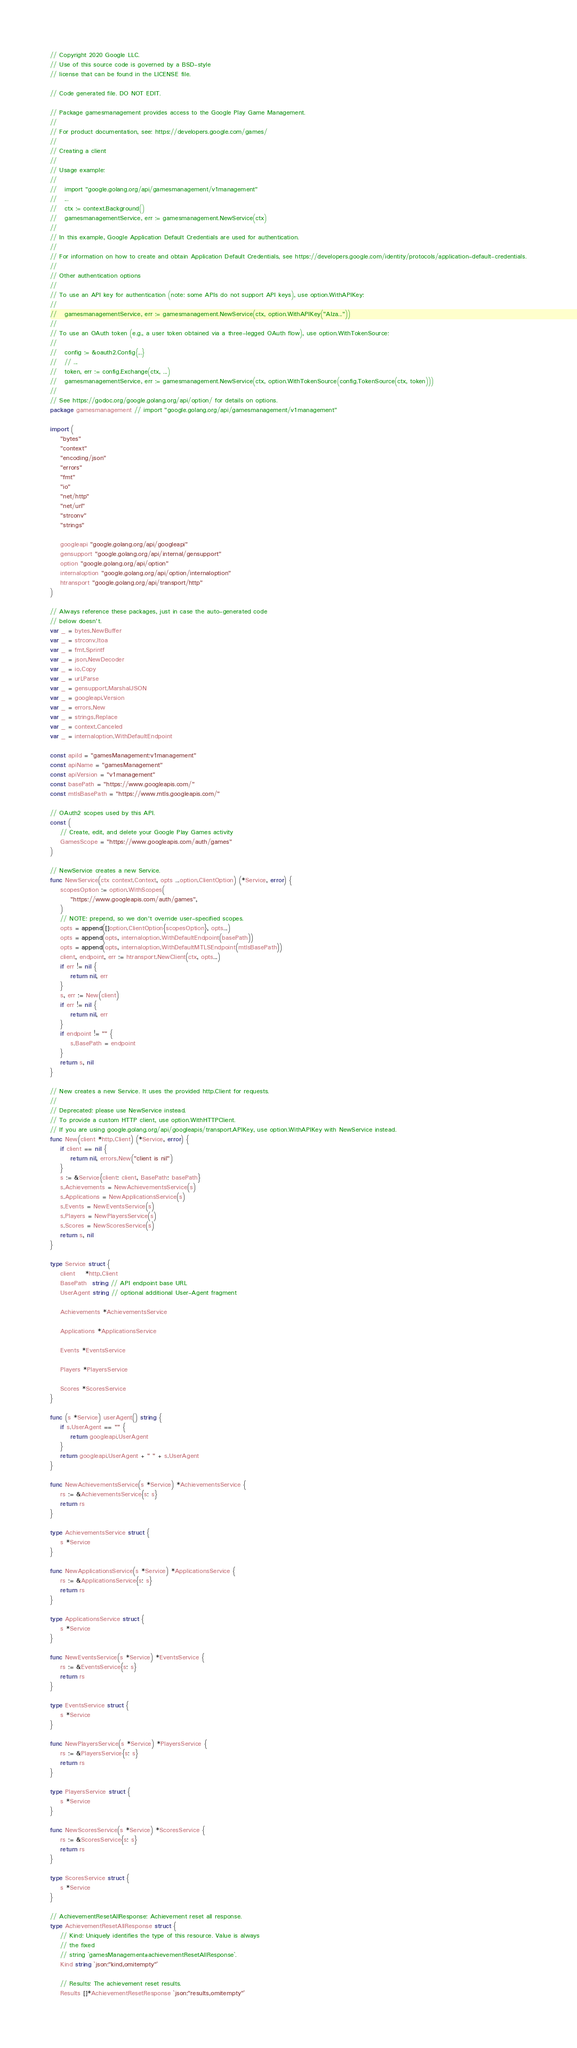Convert code to text. <code><loc_0><loc_0><loc_500><loc_500><_Go_>// Copyright 2020 Google LLC.
// Use of this source code is governed by a BSD-style
// license that can be found in the LICENSE file.

// Code generated file. DO NOT EDIT.

// Package gamesmanagement provides access to the Google Play Game Management.
//
// For product documentation, see: https://developers.google.com/games/
//
// Creating a client
//
// Usage example:
//
//   import "google.golang.org/api/gamesmanagement/v1management"
//   ...
//   ctx := context.Background()
//   gamesmanagementService, err := gamesmanagement.NewService(ctx)
//
// In this example, Google Application Default Credentials are used for authentication.
//
// For information on how to create and obtain Application Default Credentials, see https://developers.google.com/identity/protocols/application-default-credentials.
//
// Other authentication options
//
// To use an API key for authentication (note: some APIs do not support API keys), use option.WithAPIKey:
//
//   gamesmanagementService, err := gamesmanagement.NewService(ctx, option.WithAPIKey("AIza..."))
//
// To use an OAuth token (e.g., a user token obtained via a three-legged OAuth flow), use option.WithTokenSource:
//
//   config := &oauth2.Config{...}
//   // ...
//   token, err := config.Exchange(ctx, ...)
//   gamesmanagementService, err := gamesmanagement.NewService(ctx, option.WithTokenSource(config.TokenSource(ctx, token)))
//
// See https://godoc.org/google.golang.org/api/option/ for details on options.
package gamesmanagement // import "google.golang.org/api/gamesmanagement/v1management"

import (
	"bytes"
	"context"
	"encoding/json"
	"errors"
	"fmt"
	"io"
	"net/http"
	"net/url"
	"strconv"
	"strings"

	googleapi "google.golang.org/api/googleapi"
	gensupport "google.golang.org/api/internal/gensupport"
	option "google.golang.org/api/option"
	internaloption "google.golang.org/api/option/internaloption"
	htransport "google.golang.org/api/transport/http"
)

// Always reference these packages, just in case the auto-generated code
// below doesn't.
var _ = bytes.NewBuffer
var _ = strconv.Itoa
var _ = fmt.Sprintf
var _ = json.NewDecoder
var _ = io.Copy
var _ = url.Parse
var _ = gensupport.MarshalJSON
var _ = googleapi.Version
var _ = errors.New
var _ = strings.Replace
var _ = context.Canceled
var _ = internaloption.WithDefaultEndpoint

const apiId = "gamesManagement:v1management"
const apiName = "gamesManagement"
const apiVersion = "v1management"
const basePath = "https://www.googleapis.com/"
const mtlsBasePath = "https://www.mtls.googleapis.com/"

// OAuth2 scopes used by this API.
const (
	// Create, edit, and delete your Google Play Games activity
	GamesScope = "https://www.googleapis.com/auth/games"
)

// NewService creates a new Service.
func NewService(ctx context.Context, opts ...option.ClientOption) (*Service, error) {
	scopesOption := option.WithScopes(
		"https://www.googleapis.com/auth/games",
	)
	// NOTE: prepend, so we don't override user-specified scopes.
	opts = append([]option.ClientOption{scopesOption}, opts...)
	opts = append(opts, internaloption.WithDefaultEndpoint(basePath))
	opts = append(opts, internaloption.WithDefaultMTLSEndpoint(mtlsBasePath))
	client, endpoint, err := htransport.NewClient(ctx, opts...)
	if err != nil {
		return nil, err
	}
	s, err := New(client)
	if err != nil {
		return nil, err
	}
	if endpoint != "" {
		s.BasePath = endpoint
	}
	return s, nil
}

// New creates a new Service. It uses the provided http.Client for requests.
//
// Deprecated: please use NewService instead.
// To provide a custom HTTP client, use option.WithHTTPClient.
// If you are using google.golang.org/api/googleapis/transport.APIKey, use option.WithAPIKey with NewService instead.
func New(client *http.Client) (*Service, error) {
	if client == nil {
		return nil, errors.New("client is nil")
	}
	s := &Service{client: client, BasePath: basePath}
	s.Achievements = NewAchievementsService(s)
	s.Applications = NewApplicationsService(s)
	s.Events = NewEventsService(s)
	s.Players = NewPlayersService(s)
	s.Scores = NewScoresService(s)
	return s, nil
}

type Service struct {
	client    *http.Client
	BasePath  string // API endpoint base URL
	UserAgent string // optional additional User-Agent fragment

	Achievements *AchievementsService

	Applications *ApplicationsService

	Events *EventsService

	Players *PlayersService

	Scores *ScoresService
}

func (s *Service) userAgent() string {
	if s.UserAgent == "" {
		return googleapi.UserAgent
	}
	return googleapi.UserAgent + " " + s.UserAgent
}

func NewAchievementsService(s *Service) *AchievementsService {
	rs := &AchievementsService{s: s}
	return rs
}

type AchievementsService struct {
	s *Service
}

func NewApplicationsService(s *Service) *ApplicationsService {
	rs := &ApplicationsService{s: s}
	return rs
}

type ApplicationsService struct {
	s *Service
}

func NewEventsService(s *Service) *EventsService {
	rs := &EventsService{s: s}
	return rs
}

type EventsService struct {
	s *Service
}

func NewPlayersService(s *Service) *PlayersService {
	rs := &PlayersService{s: s}
	return rs
}

type PlayersService struct {
	s *Service
}

func NewScoresService(s *Service) *ScoresService {
	rs := &ScoresService{s: s}
	return rs
}

type ScoresService struct {
	s *Service
}

// AchievementResetAllResponse: Achievement reset all response.
type AchievementResetAllResponse struct {
	// Kind: Uniquely identifies the type of this resource. Value is always
	// the fixed
	// string `gamesManagement#achievementResetAllResponse`.
	Kind string `json:"kind,omitempty"`

	// Results: The achievement reset results.
	Results []*AchievementResetResponse `json:"results,omitempty"`
</code> 